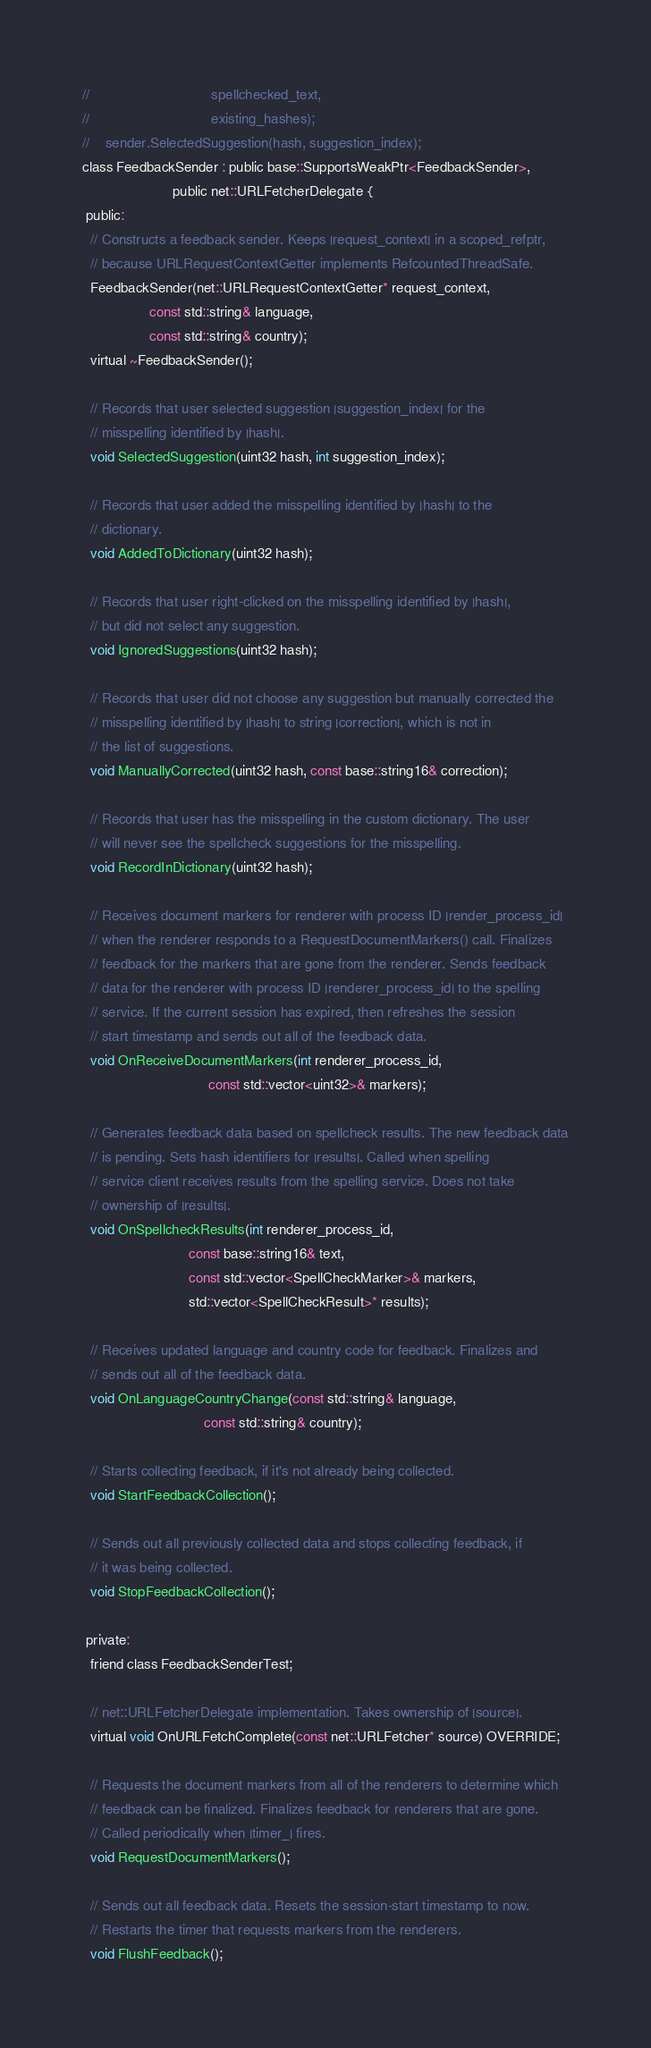<code> <loc_0><loc_0><loc_500><loc_500><_C_>//                               spellchecked_text,
//                               existing_hashes);
//    sender.SelectedSuggestion(hash, suggestion_index);
class FeedbackSender : public base::SupportsWeakPtr<FeedbackSender>,
                       public net::URLFetcherDelegate {
 public:
  // Constructs a feedback sender. Keeps |request_context| in a scoped_refptr,
  // because URLRequestContextGetter implements RefcountedThreadSafe.
  FeedbackSender(net::URLRequestContextGetter* request_context,
                 const std::string& language,
                 const std::string& country);
  virtual ~FeedbackSender();

  // Records that user selected suggestion |suggestion_index| for the
  // misspelling identified by |hash|.
  void SelectedSuggestion(uint32 hash, int suggestion_index);

  // Records that user added the misspelling identified by |hash| to the
  // dictionary.
  void AddedToDictionary(uint32 hash);

  // Records that user right-clicked on the misspelling identified by |hash|,
  // but did not select any suggestion.
  void IgnoredSuggestions(uint32 hash);

  // Records that user did not choose any suggestion but manually corrected the
  // misspelling identified by |hash| to string |correction|, which is not in
  // the list of suggestions.
  void ManuallyCorrected(uint32 hash, const base::string16& correction);

  // Records that user has the misspelling in the custom dictionary. The user
  // will never see the spellcheck suggestions for the misspelling.
  void RecordInDictionary(uint32 hash);

  // Receives document markers for renderer with process ID |render_process_id|
  // when the renderer responds to a RequestDocumentMarkers() call. Finalizes
  // feedback for the markers that are gone from the renderer. Sends feedback
  // data for the renderer with process ID |renderer_process_id| to the spelling
  // service. If the current session has expired, then refreshes the session
  // start timestamp and sends out all of the feedback data.
  void OnReceiveDocumentMarkers(int renderer_process_id,
                                const std::vector<uint32>& markers);

  // Generates feedback data based on spellcheck results. The new feedback data
  // is pending. Sets hash identifiers for |results|. Called when spelling
  // service client receives results from the spelling service. Does not take
  // ownership of |results|.
  void OnSpellcheckResults(int renderer_process_id,
                           const base::string16& text,
                           const std::vector<SpellCheckMarker>& markers,
                           std::vector<SpellCheckResult>* results);

  // Receives updated language and country code for feedback. Finalizes and
  // sends out all of the feedback data.
  void OnLanguageCountryChange(const std::string& language,
                               const std::string& country);

  // Starts collecting feedback, if it's not already being collected.
  void StartFeedbackCollection();

  // Sends out all previously collected data and stops collecting feedback, if
  // it was being collected.
  void StopFeedbackCollection();

 private:
  friend class FeedbackSenderTest;

  // net::URLFetcherDelegate implementation. Takes ownership of |source|.
  virtual void OnURLFetchComplete(const net::URLFetcher* source) OVERRIDE;

  // Requests the document markers from all of the renderers to determine which
  // feedback can be finalized. Finalizes feedback for renderers that are gone.
  // Called periodically when |timer_| fires.
  void RequestDocumentMarkers();

  // Sends out all feedback data. Resets the session-start timestamp to now.
  // Restarts the timer that requests markers from the renderers.
  void FlushFeedback();
</code> 